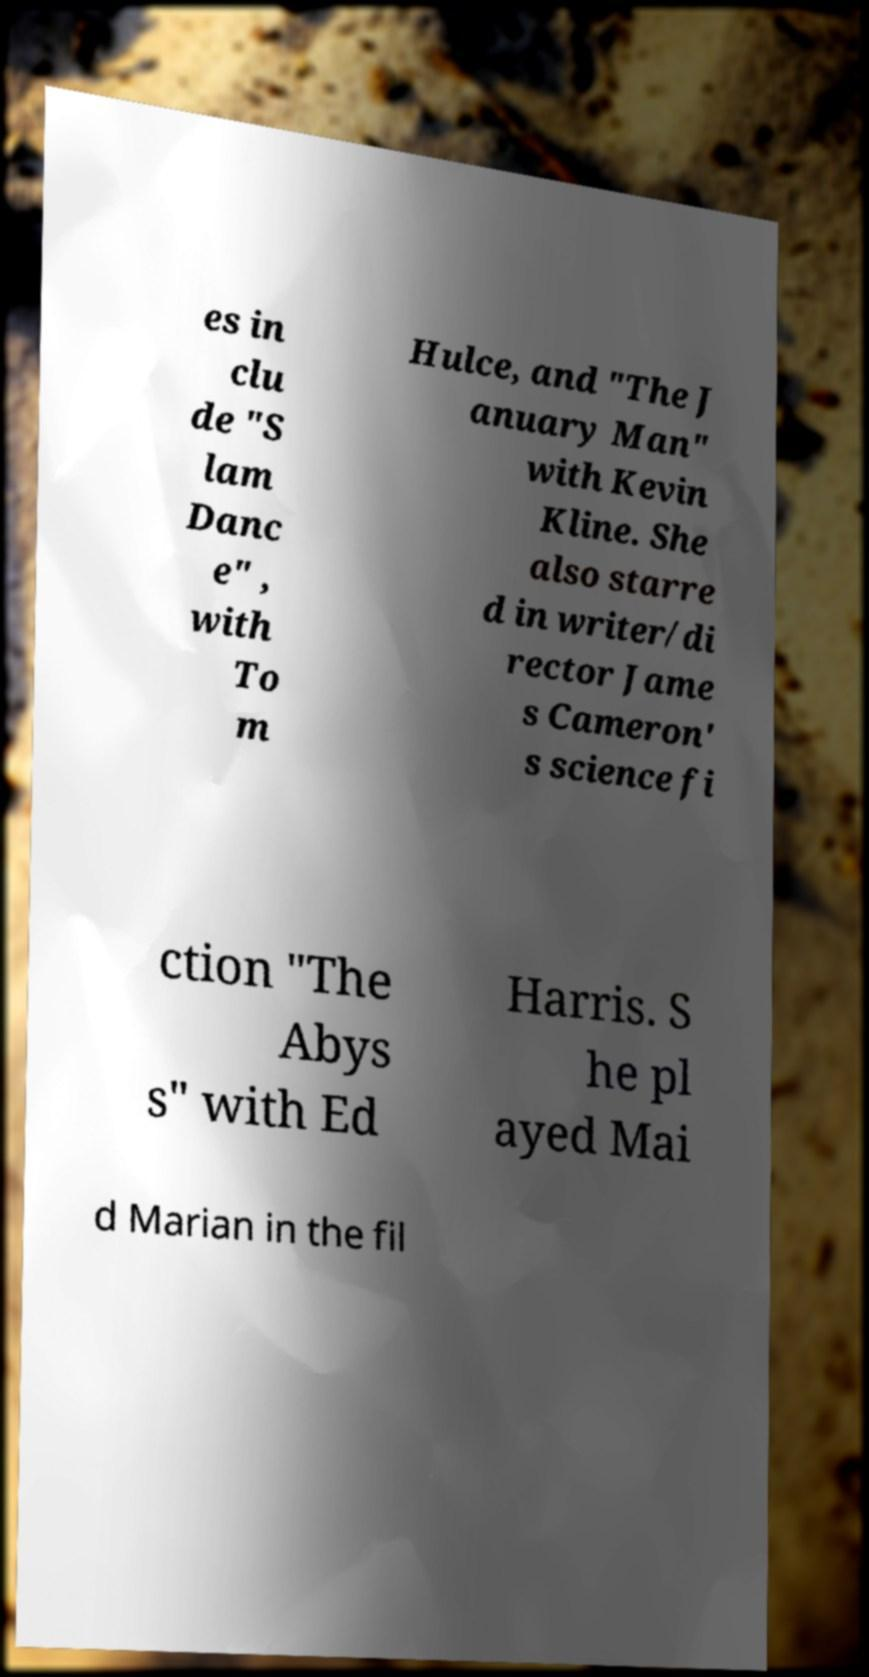Can you accurately transcribe the text from the provided image for me? es in clu de "S lam Danc e" , with To m Hulce, and "The J anuary Man" with Kevin Kline. She also starre d in writer/di rector Jame s Cameron' s science fi ction "The Abys s" with Ed Harris. S he pl ayed Mai d Marian in the fil 